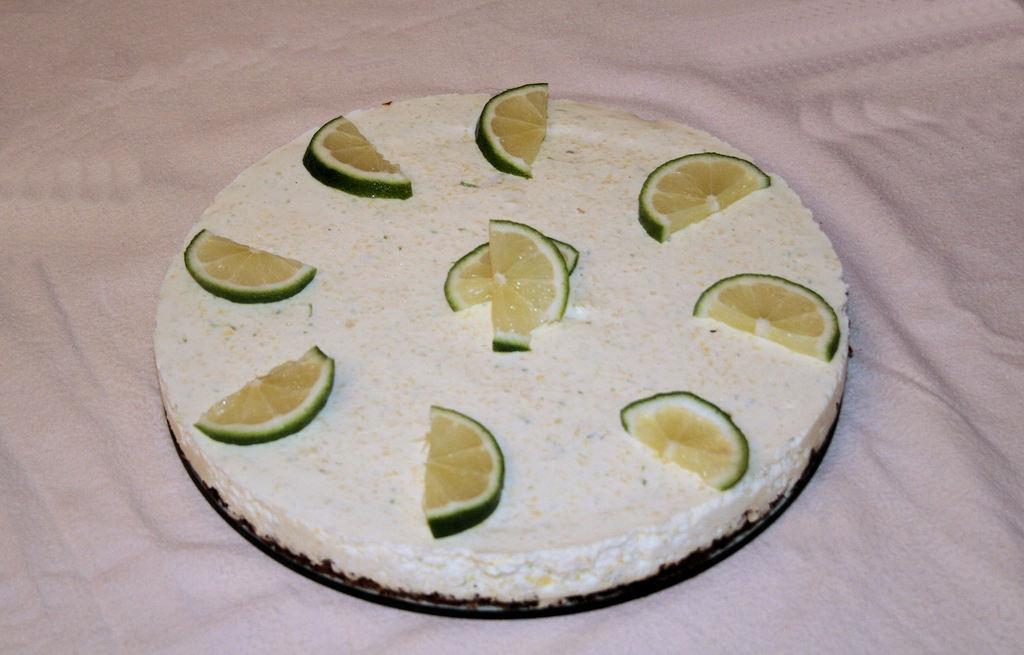How would you summarize this image in a sentence or two? In this picture there is a cake on the bed. On the cake we can see an orange pieces. At the top there is a pink color bed sheet. 